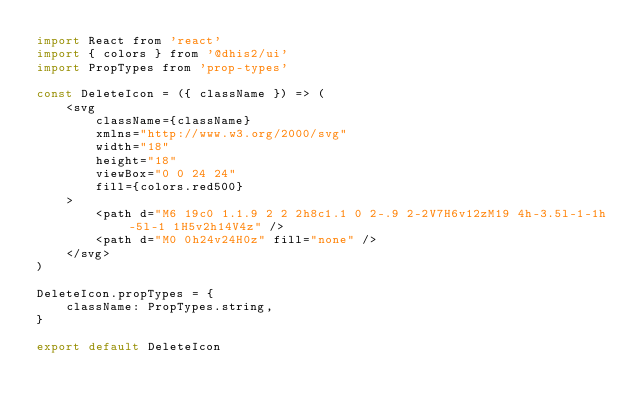<code> <loc_0><loc_0><loc_500><loc_500><_JavaScript_>import React from 'react'
import { colors } from '@dhis2/ui'
import PropTypes from 'prop-types'

const DeleteIcon = ({ className }) => (
    <svg
        className={className}
        xmlns="http://www.w3.org/2000/svg"
        width="18"
        height="18"
        viewBox="0 0 24 24"
        fill={colors.red500}
    >
        <path d="M6 19c0 1.1.9 2 2 2h8c1.1 0 2-.9 2-2V7H6v12zM19 4h-3.5l-1-1h-5l-1 1H5v2h14V4z" />
        <path d="M0 0h24v24H0z" fill="none" />
    </svg>
)

DeleteIcon.propTypes = {
    className: PropTypes.string,
}

export default DeleteIcon
</code> 